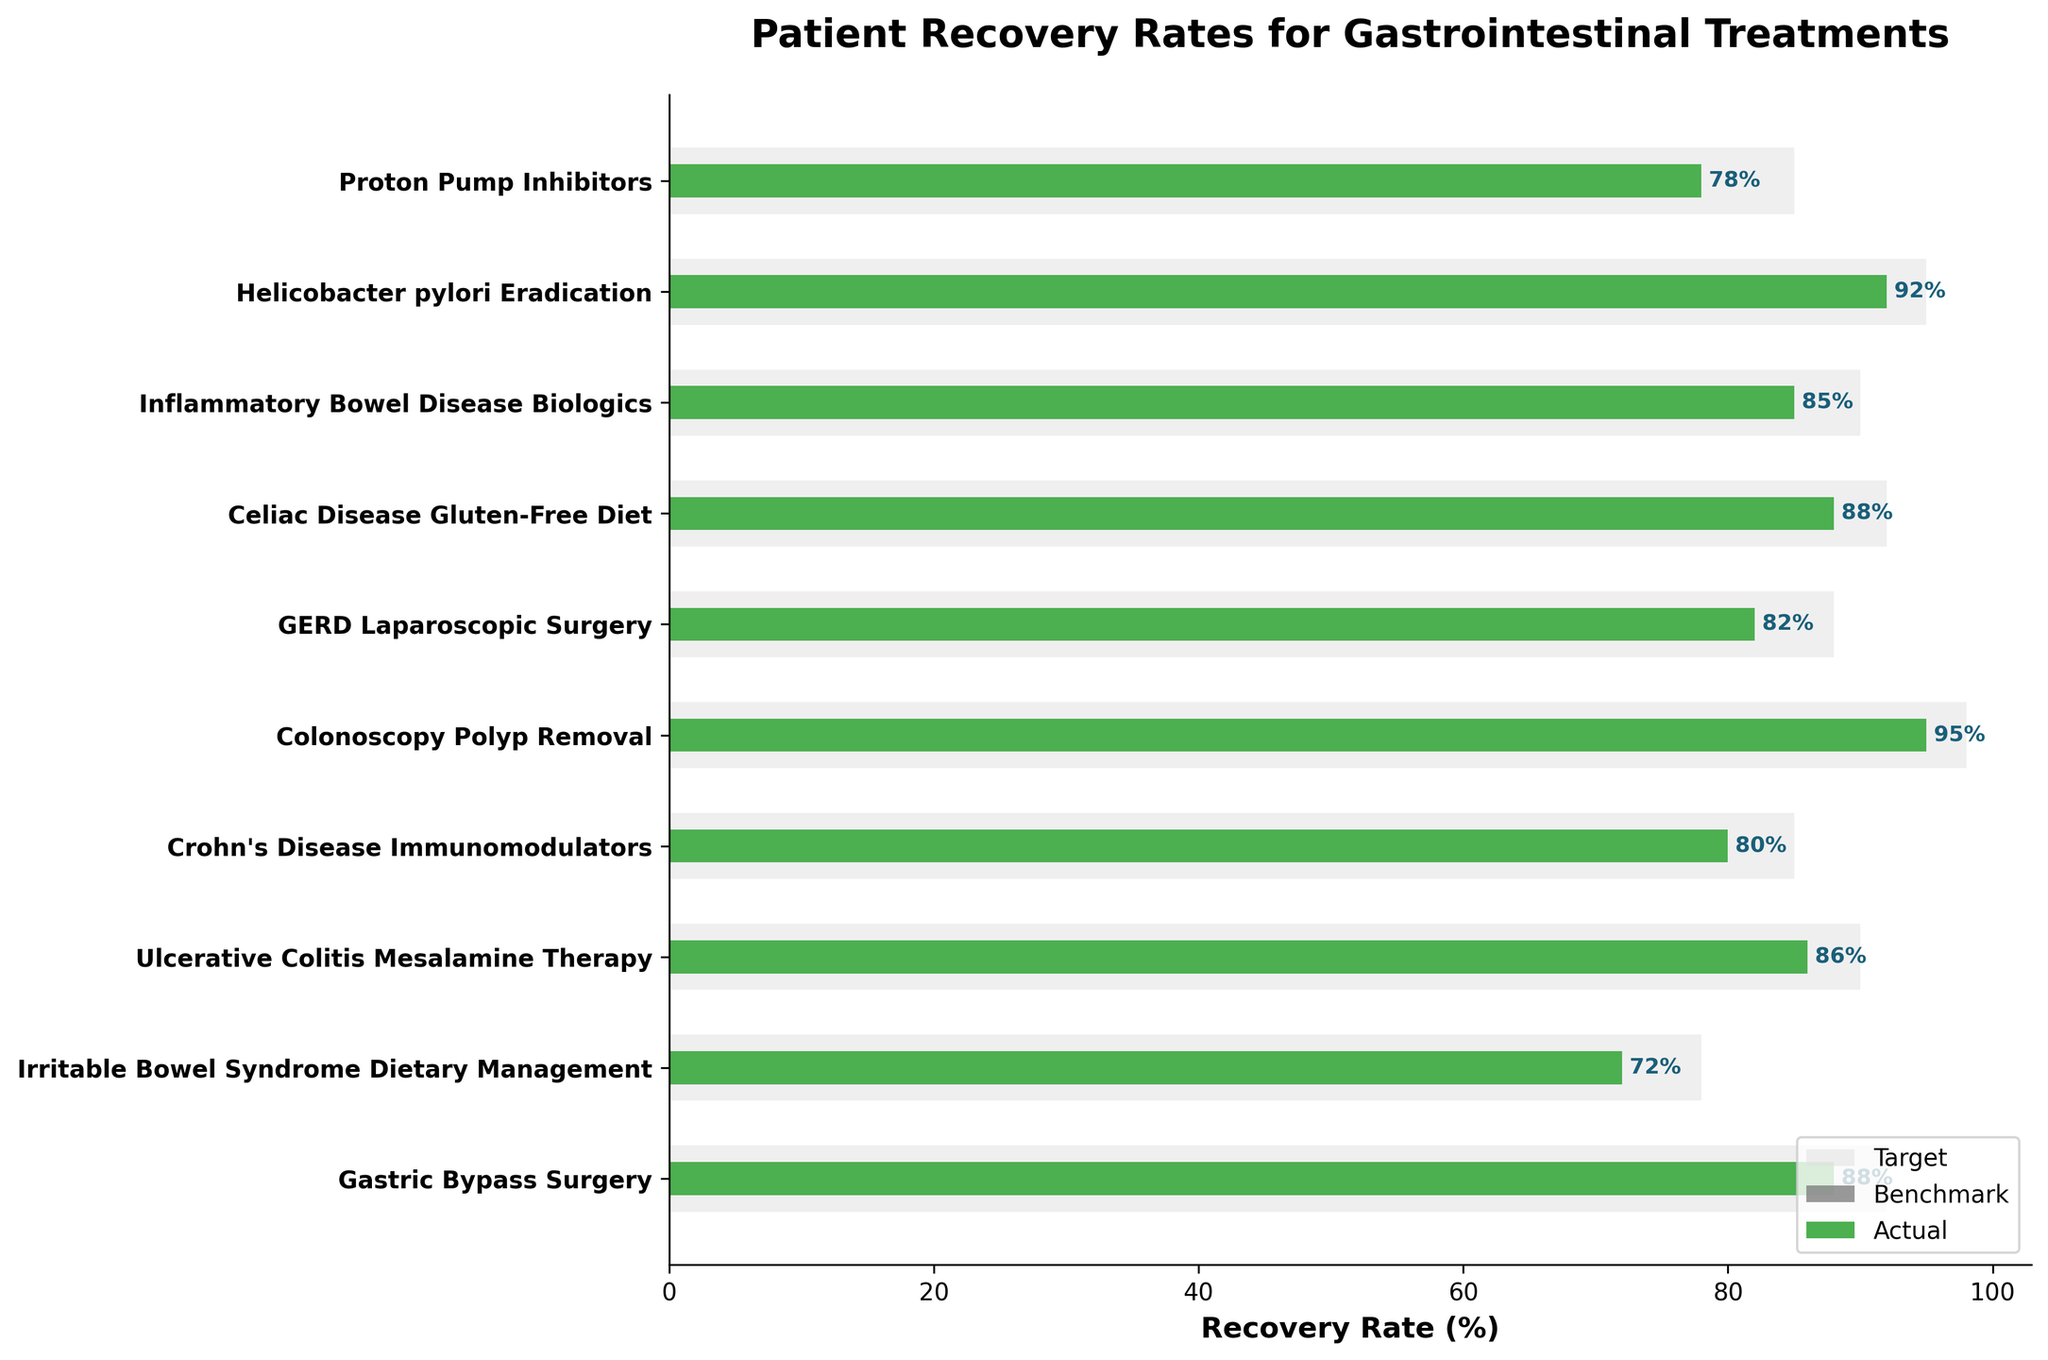What is the title of the figure? The title is usually displayed at the top of the plot and provides a brief summary of what the chart is about.
Answer: Patient Recovery Rates for Gastrointestinal Treatments What treatment has the highest actual recovery rate? Look for the longest green bar which represents the actual recovery rate.
Answer: Colonoscopy Polyp Removal Which treatment has the lowest actual recovery rate? Identify the shortest green bar on the chart, as this represents the lowest actual recovery rate.
Answer: Irritable Bowel Syndrome Dietary Management What is the actual recovery rate for Inflammatory Bowel Disease Biologics? Locate the green bar corresponding to the treatment labeled "Inflammatory Bowel Disease Biologics" and read its value.
Answer: 85% How does the actual recovery rate for Helicobacter pylori Eradication compare to its benchmark? Find the green bar for Helicobacter pylori Eradication and compare its length with the grey bar directly behind it, which represents the benchmark.
Answer: Higher What is the difference between the actual and target recovery rates for GERD Laparoscopic Surgery? The difference can be calculated by subtracting the actual recovery rate from the target recovery rate for GERD Laparoscopic Surgery (88 - 82).
Answer: 6% Which treatment has an actual recovery rate equal to its benchmark? Look for a bar where the green and grey parts are of the same length.
Answer: None How many treatments have a target greater than their actual recovery rate? Count the number of treatments where the target bar is longer than the actual bar.
Answer: 10 Does any treatment meet or exceed its target recovery rate? Compare each actual bar to its corresponding target bar.
Answer: No For Crohn's Disease Immunomodulators, what is the amount the actual recovery rate falls short of the target? Subtract the actual value from the target value for Crohn's Disease Immunomodulators (85 - 80).
Answer: 5% 